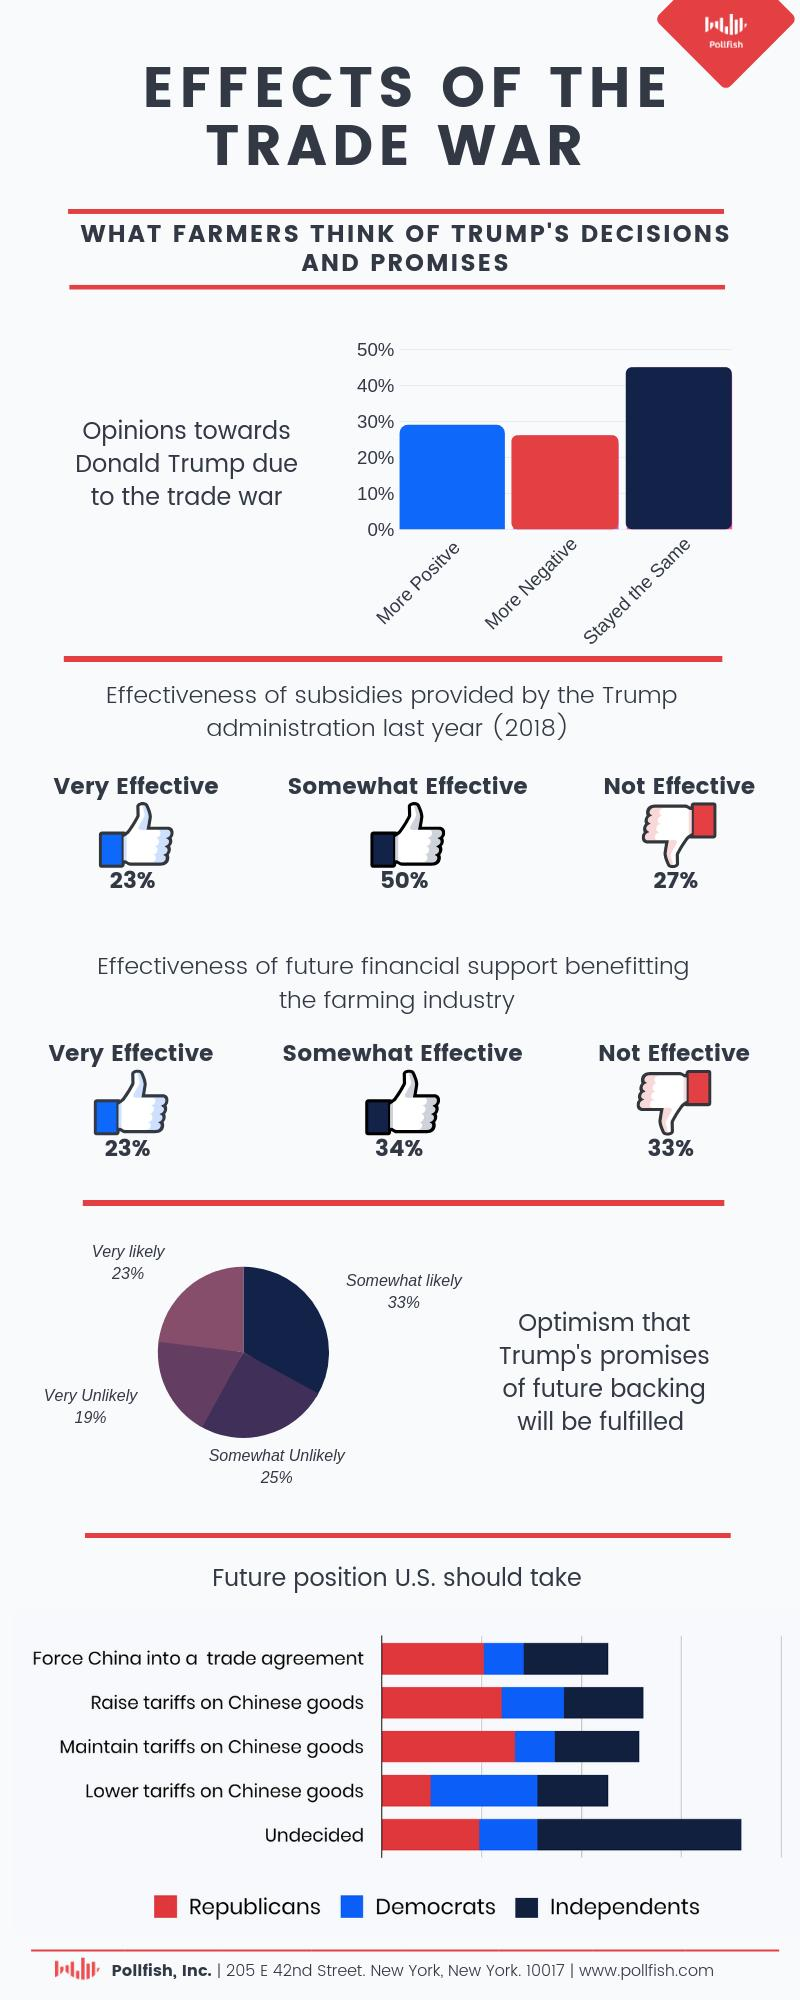Point out several critical features in this image. A recent survey has revealed that 56% of people are hopeful that President Trump's promises of future backing will be fulfilled. A survey conducted last year revealed that 73% of people responded positively on the effectiveness of subsidies provided by President Trump. According to a recent survey, it is estimated that only 44% of people believe that Trump's promises of future backing will be fulfilled. In the survey of future financial support, 57% of the respondents reported that they felt the support was effective. According to a recent poll, approximately 45% of the opinions regarding Trump's policies remain unchanged. 